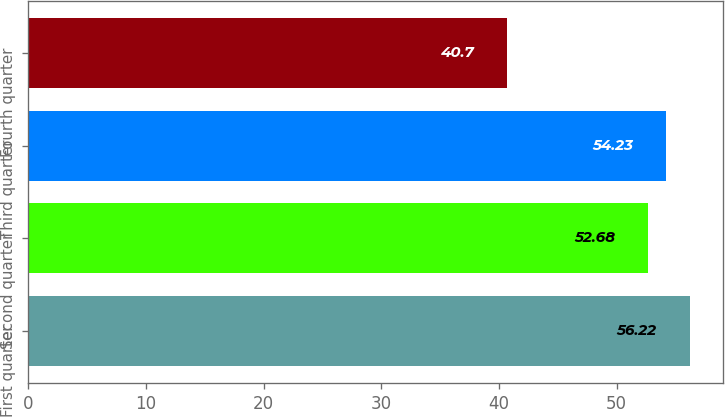Convert chart. <chart><loc_0><loc_0><loc_500><loc_500><bar_chart><fcel>First quarter<fcel>Second quarter<fcel>Third quarter<fcel>Fourth quarter<nl><fcel>56.22<fcel>52.68<fcel>54.23<fcel>40.7<nl></chart> 